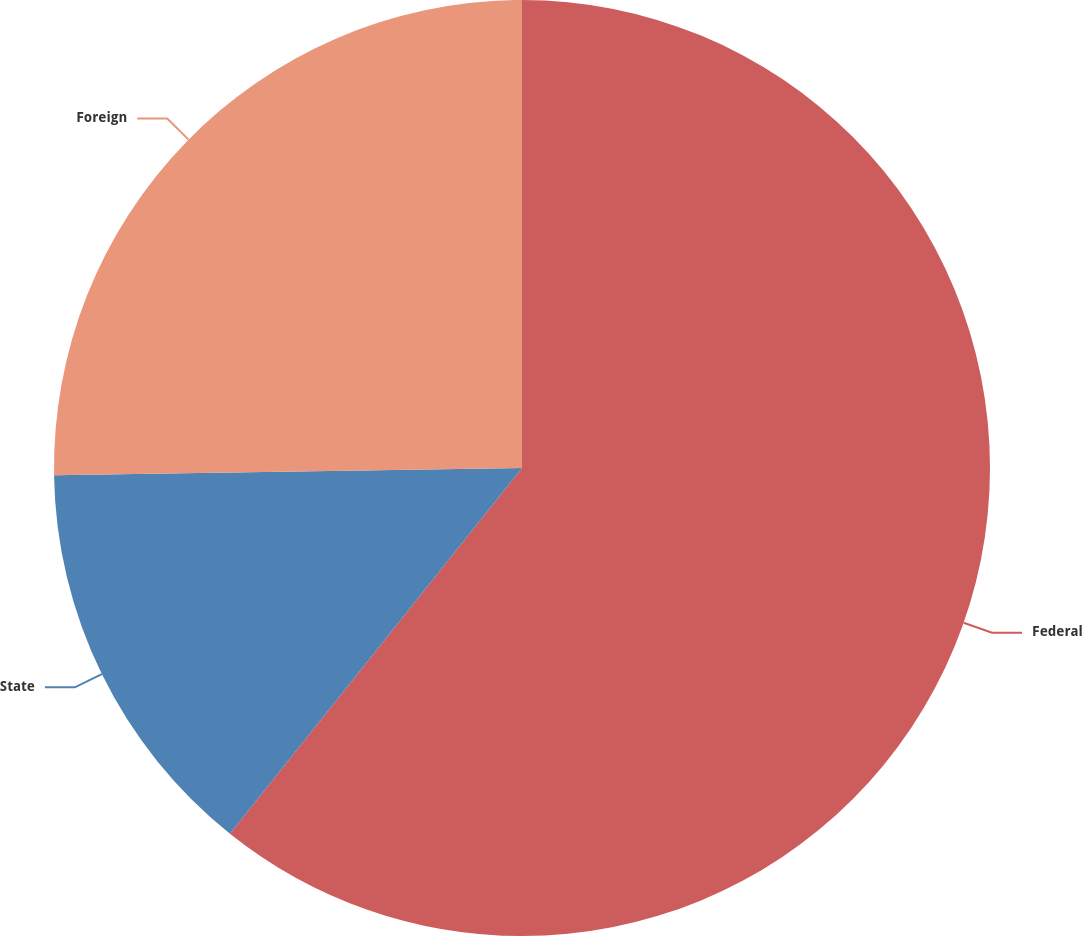Convert chart to OTSL. <chart><loc_0><loc_0><loc_500><loc_500><pie_chart><fcel>Federal<fcel>State<fcel>Foreign<nl><fcel>60.72%<fcel>14.03%<fcel>25.24%<nl></chart> 